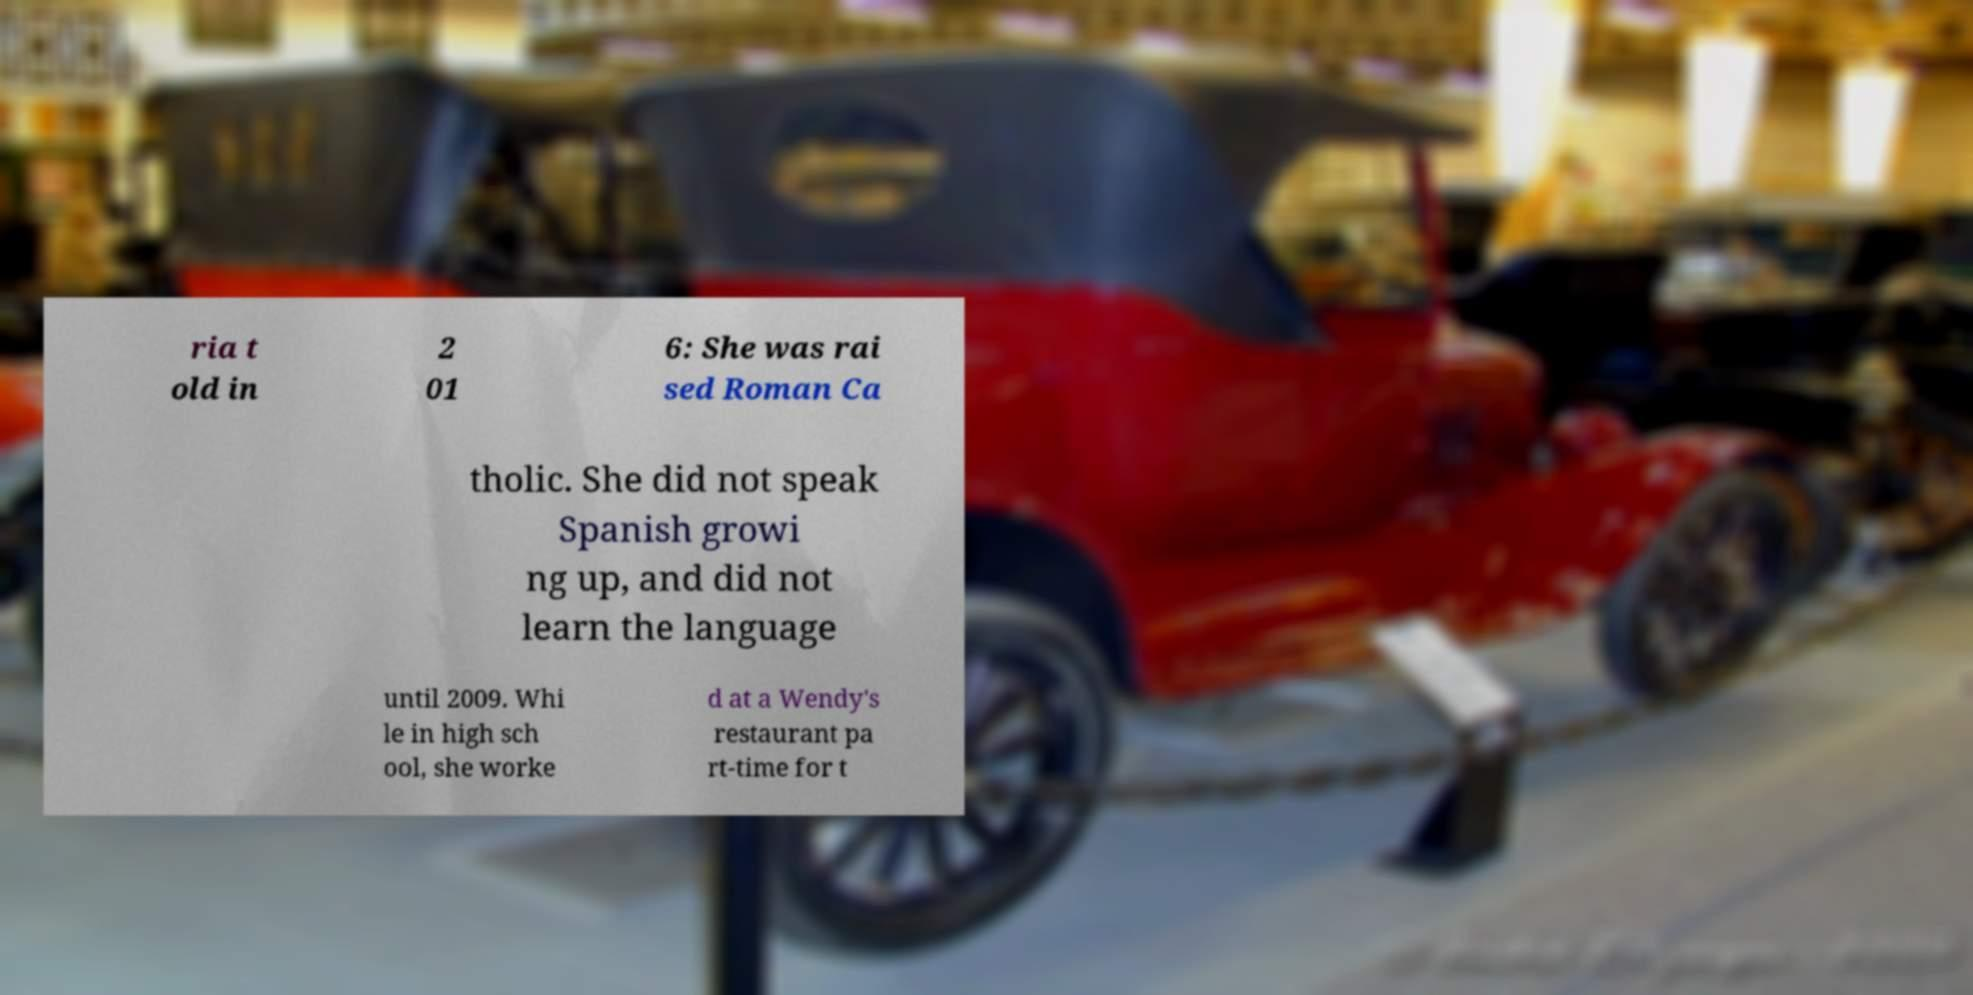For documentation purposes, I need the text within this image transcribed. Could you provide that? ria t old in 2 01 6: She was rai sed Roman Ca tholic. She did not speak Spanish growi ng up, and did not learn the language until 2009. Whi le in high sch ool, she worke d at a Wendy's restaurant pa rt-time for t 